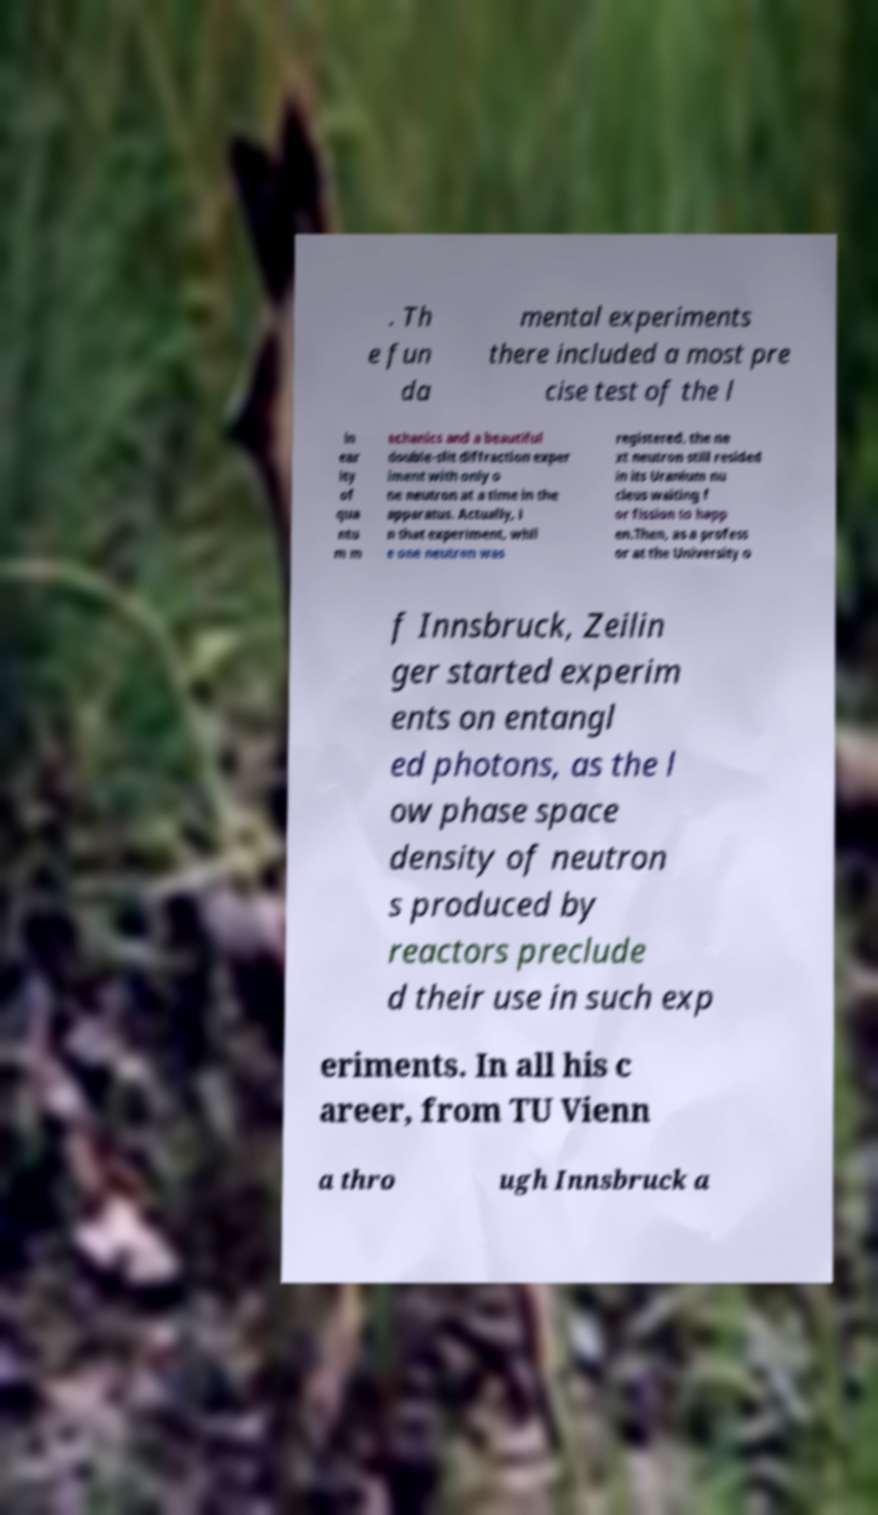Could you assist in decoding the text presented in this image and type it out clearly? . Th e fun da mental experiments there included a most pre cise test of the l in ear ity of qua ntu m m echanics and a beautiful double-slit diffraction exper iment with only o ne neutron at a time in the apparatus. Actually, i n that experiment, whil e one neutron was registered, the ne xt neutron still resided in its Uranium nu cleus waiting f or fission to happ en.Then, as a profess or at the University o f Innsbruck, Zeilin ger started experim ents on entangl ed photons, as the l ow phase space density of neutron s produced by reactors preclude d their use in such exp eriments. In all his c areer, from TU Vienn a thro ugh Innsbruck a 